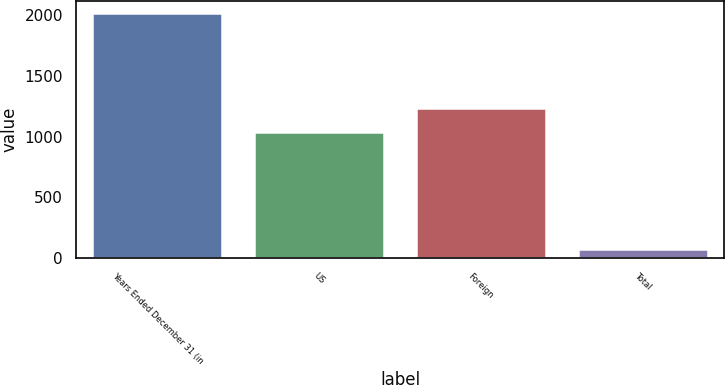Convert chart to OTSL. <chart><loc_0><loc_0><loc_500><loc_500><bar_chart><fcel>Years Ended December 31 (in<fcel>US<fcel>Foreign<fcel>Total<nl><fcel>2016<fcel>1041<fcel>1235.2<fcel>74<nl></chart> 